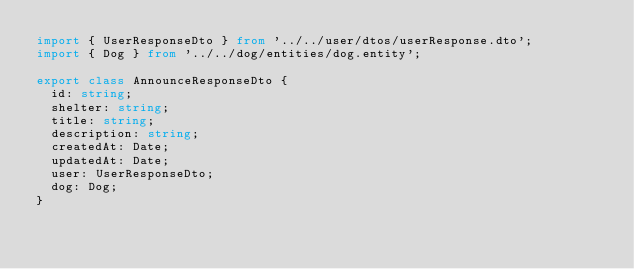<code> <loc_0><loc_0><loc_500><loc_500><_TypeScript_>import { UserResponseDto } from '../../user/dtos/userResponse.dto';
import { Dog } from '../../dog/entities/dog.entity';

export class AnnounceResponseDto {
  id: string;
  shelter: string;
  title: string;
  description: string;
  createdAt: Date;
  updatedAt: Date;
  user: UserResponseDto;
  dog: Dog;
}
</code> 